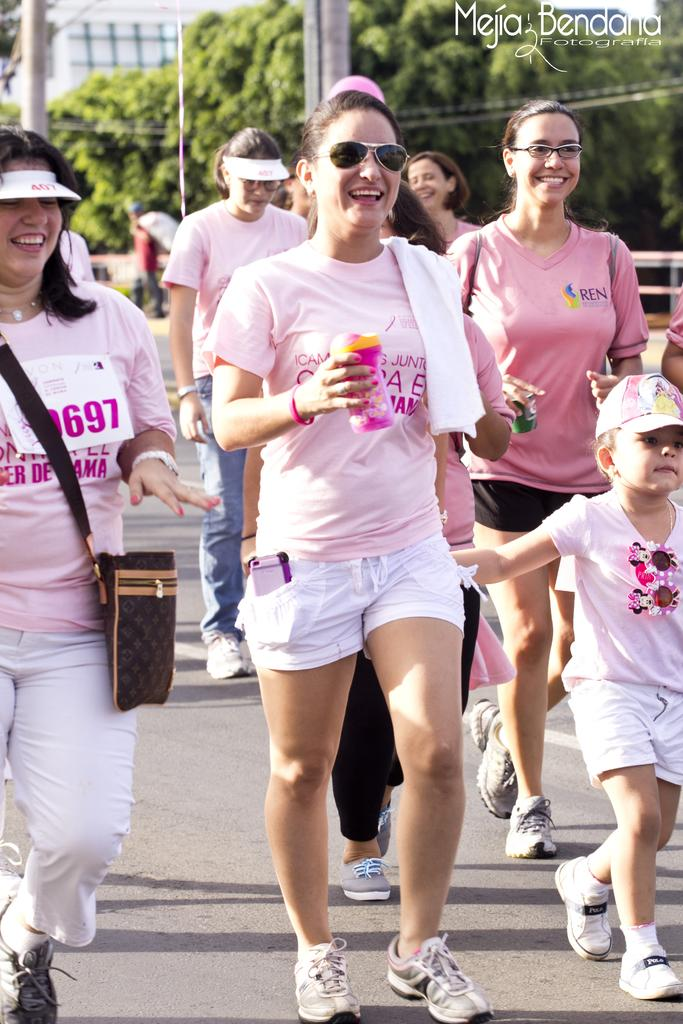What are the people in the image doing? The people in the image are walking on the road. What can be seen in the background of the image? There are trees and buildings visible in the background of the image. What type of books can be found in the library in the image? There is no library present in the image; it features people walking on the road and trees and buildings in the background. 